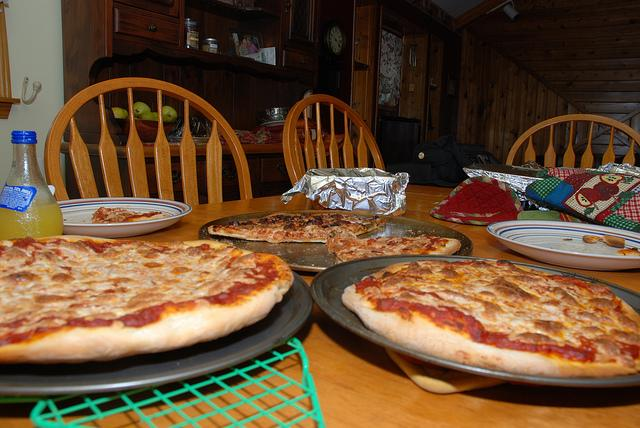The glass drink on the table has what as its primary flavor? orange 